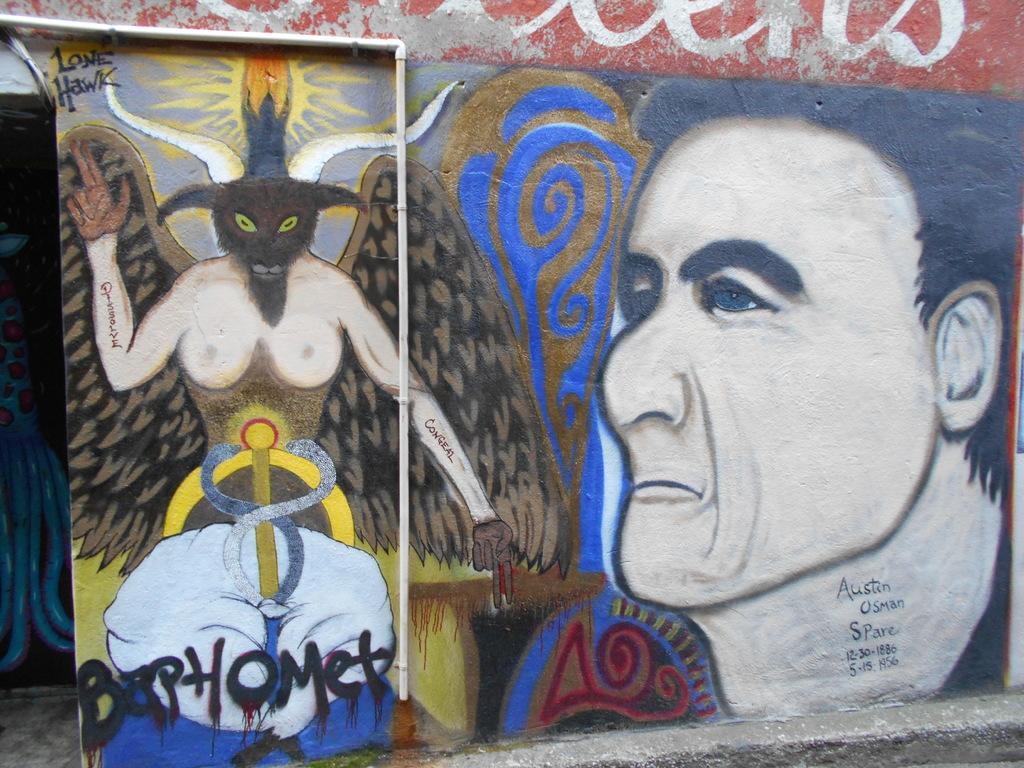Describe this image in one or two sentences. In this image there is a wall with a painting of a man and an animal on it. 